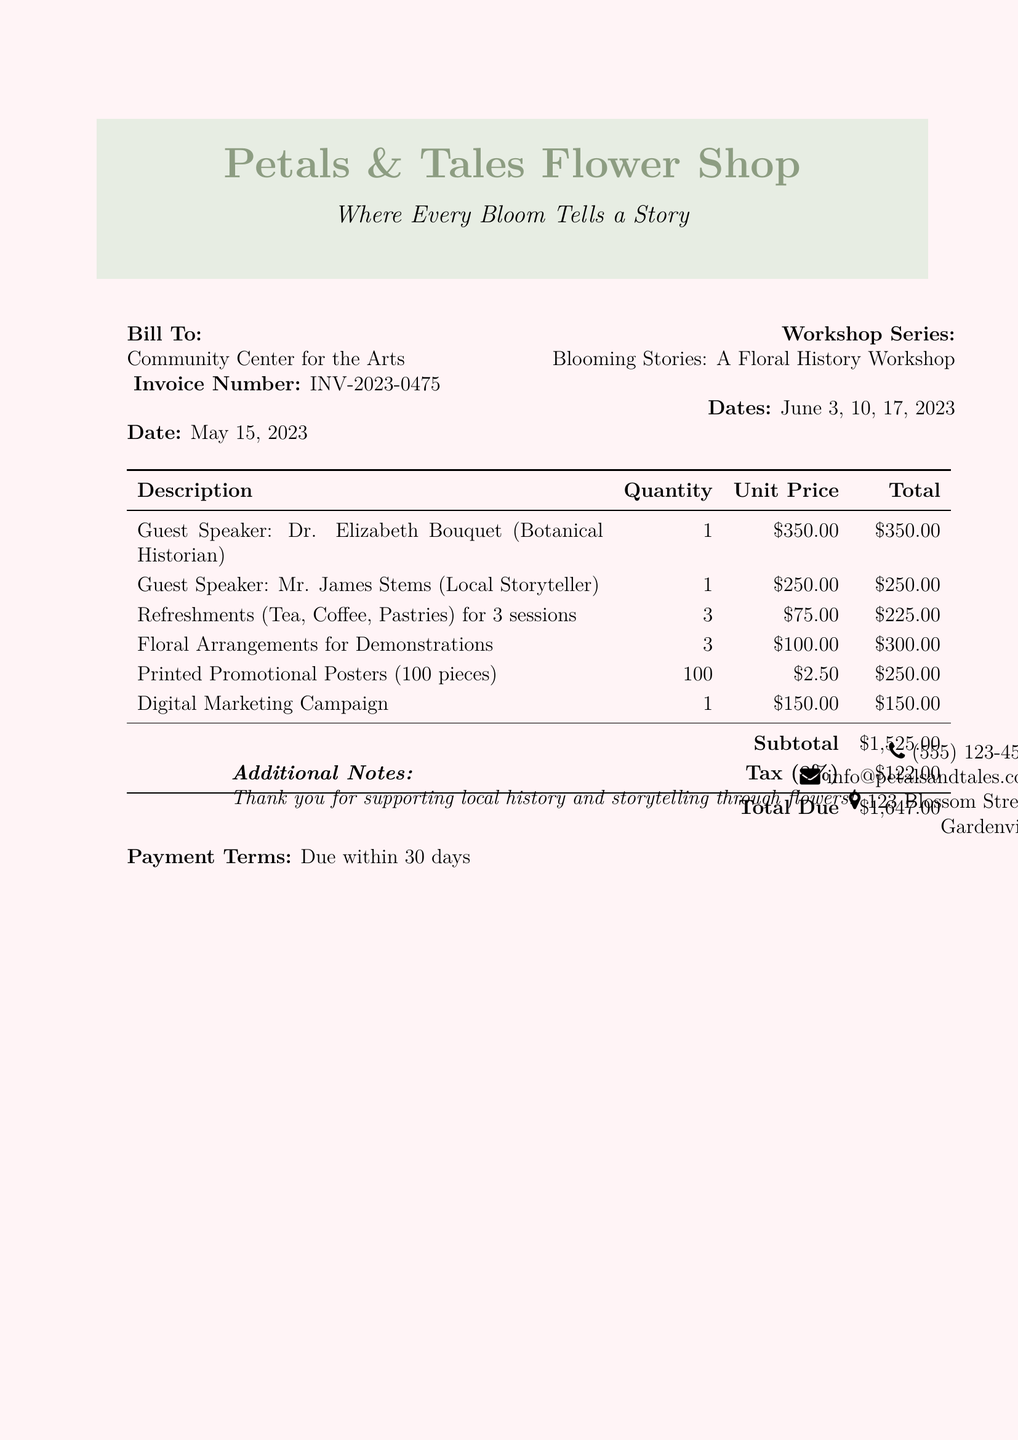What is the invoice number? The invoice number is specified in the document to uniquely identify the transaction, which is INV-2023-0475.
Answer: INV-2023-0475 Who are the guest speakers? The document lists the guest speakers for the workshop series, which includes Dr. Elizabeth Bouquet and Mr. James Stems.
Answer: Dr. Elizabeth Bouquet, Mr. James Stems What is the date of the workshop series? The date of the workshop series is provided at the top of the document, which includes June 3, 10, and 17, 2023.
Answer: June 3, 10, 17, 2023 What is the total due amount? The total due amount is calculated by adding the subtotal and tax, and is stated clearly in the document as $1,647.00.
Answer: $1,647.00 How much does each guest speaker cost? The document specifies the individual costs for each guest speaker: Dr. Elizabeth Bouquet costs $350.00 and Mr. James Stems costs $250.00.
Answer: $350.00, $250.00 What is included in the refreshments? The document details the refreshments provided for the workshop series, which includes tea, coffee, and pastries.
Answer: Tea, Coffee, Pastries What is the tax rate applied? The tax applied to the subtotal is mentioned in the document as 8%.
Answer: 8% How many printed promotional posters are included? The document specifies the quantity of printed promotional posters, which is stated as 100 pieces.
Answer: 100 pieces 